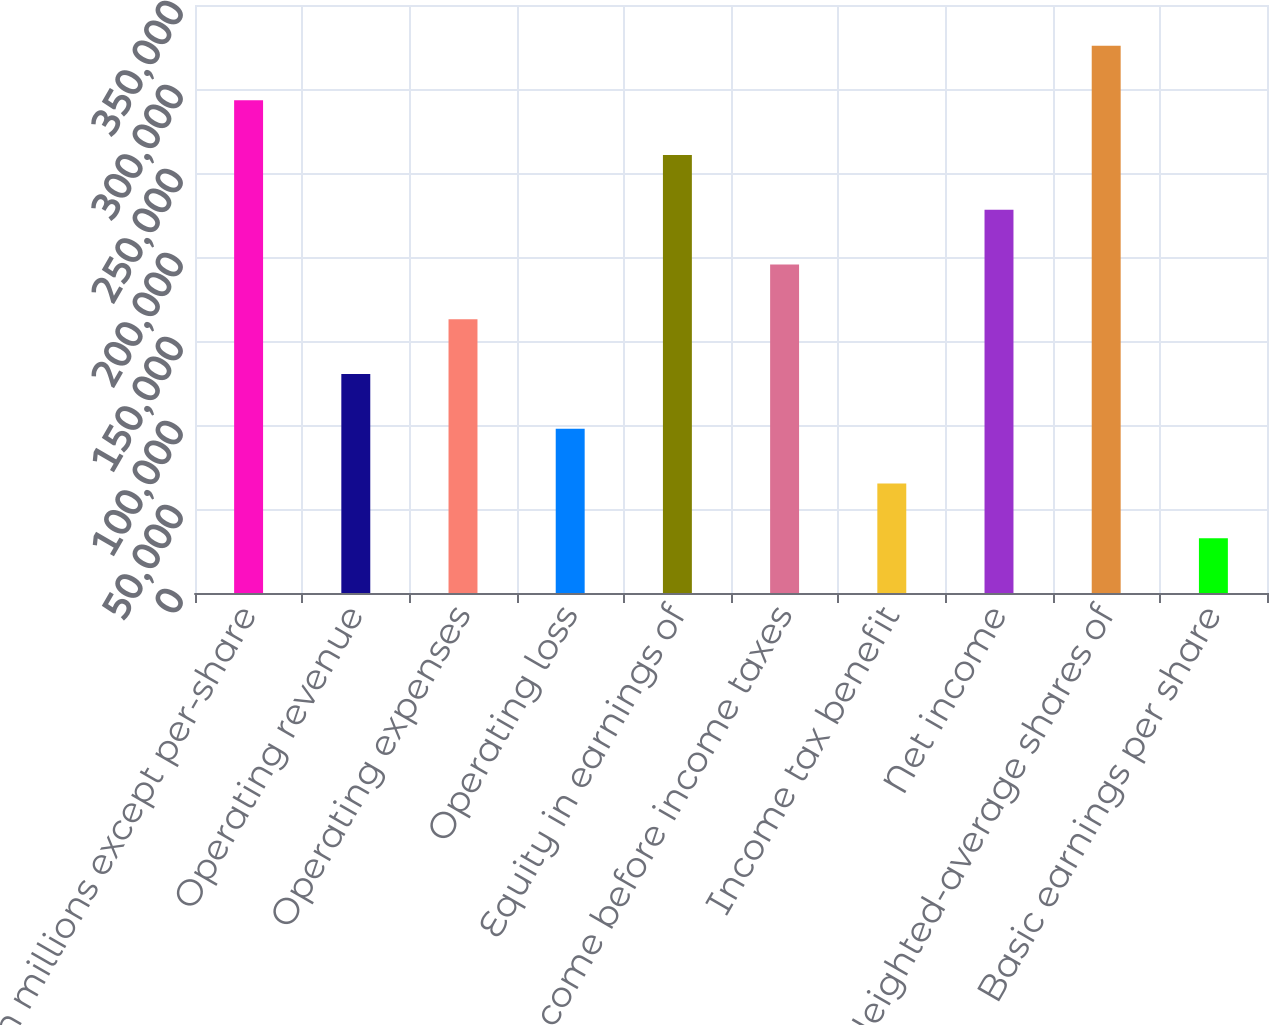<chart> <loc_0><loc_0><loc_500><loc_500><bar_chart><fcel>(in millions except per-share<fcel>Operating revenue<fcel>Operating expenses<fcel>Operating loss<fcel>Equity in earnings of<fcel>Income before income taxes<fcel>Income tax benefit<fcel>Net income<fcel>Weighted-average shares of<fcel>Basic earnings per share<nl><fcel>293230<fcel>130326<fcel>162907<fcel>97745.6<fcel>260649<fcel>195488<fcel>65164.8<fcel>228069<fcel>325811<fcel>32584.1<nl></chart> 